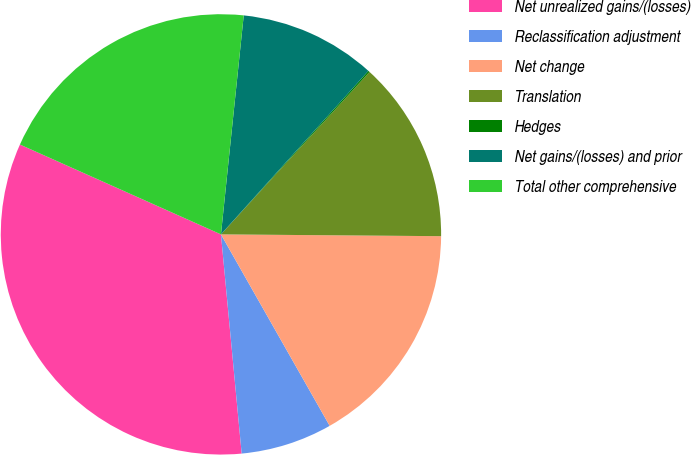<chart> <loc_0><loc_0><loc_500><loc_500><pie_chart><fcel>Net unrealized gains/(losses)<fcel>Reclassification adjustment<fcel>Net change<fcel>Translation<fcel>Hedges<fcel>Net gains/(losses) and prior<fcel>Total other comprehensive<nl><fcel>33.19%<fcel>6.72%<fcel>16.65%<fcel>13.34%<fcel>0.11%<fcel>10.03%<fcel>19.96%<nl></chart> 